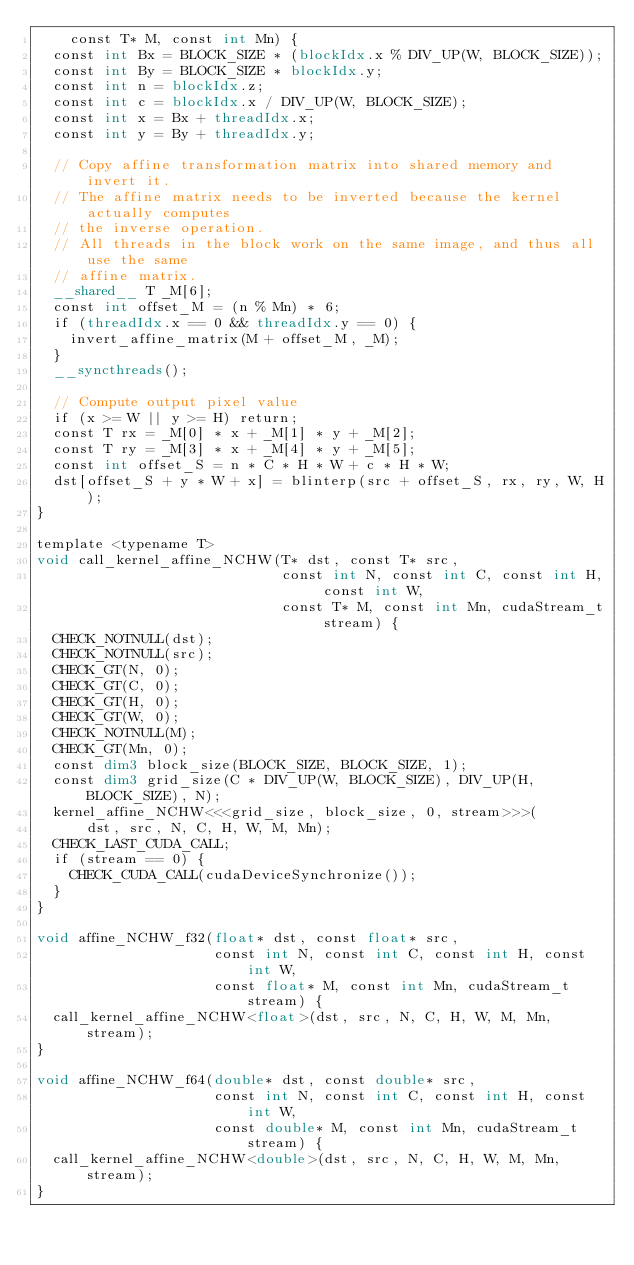Convert code to text. <code><loc_0><loc_0><loc_500><loc_500><_Cuda_>    const T* M, const int Mn) {
  const int Bx = BLOCK_SIZE * (blockIdx.x % DIV_UP(W, BLOCK_SIZE));
  const int By = BLOCK_SIZE * blockIdx.y;
  const int n = blockIdx.z;
  const int c = blockIdx.x / DIV_UP(W, BLOCK_SIZE);
  const int x = Bx + threadIdx.x;
  const int y = By + threadIdx.y;

  // Copy affine transformation matrix into shared memory and invert it.
  // The affine matrix needs to be inverted because the kernel actually computes
  // the inverse operation.
  // All threads in the block work on the same image, and thus all use the same
  // affine matrix.
  __shared__ T _M[6];
  const int offset_M = (n % Mn) * 6;
  if (threadIdx.x == 0 && threadIdx.y == 0) {
    invert_affine_matrix(M + offset_M, _M);
  }
  __syncthreads();

  // Compute output pixel value
  if (x >= W || y >= H) return;
  const T rx = _M[0] * x + _M[1] * y + _M[2];
  const T ry = _M[3] * x + _M[4] * y + _M[5];
  const int offset_S = n * C * H * W + c * H * W;
  dst[offset_S + y * W + x] = blinterp(src + offset_S, rx, ry, W, H);
}

template <typename T>
void call_kernel_affine_NCHW(T* dst, const T* src,
                             const int N, const int C, const int H, const int W,
                             const T* M, const int Mn, cudaStream_t stream) {
  CHECK_NOTNULL(dst);
  CHECK_NOTNULL(src);
  CHECK_GT(N, 0);
  CHECK_GT(C, 0);
  CHECK_GT(H, 0);
  CHECK_GT(W, 0);
  CHECK_NOTNULL(M);
  CHECK_GT(Mn, 0);
  const dim3 block_size(BLOCK_SIZE, BLOCK_SIZE, 1);
  const dim3 grid_size(C * DIV_UP(W, BLOCK_SIZE), DIV_UP(H, BLOCK_SIZE), N);
  kernel_affine_NCHW<<<grid_size, block_size, 0, stream>>>(
      dst, src, N, C, H, W, M, Mn);
  CHECK_LAST_CUDA_CALL;
  if (stream == 0) {
    CHECK_CUDA_CALL(cudaDeviceSynchronize());
  }
}

void affine_NCHW_f32(float* dst, const float* src,
                     const int N, const int C, const int H, const int W,
                     const float* M, const int Mn, cudaStream_t stream) {
  call_kernel_affine_NCHW<float>(dst, src, N, C, H, W, M, Mn, stream);
}

void affine_NCHW_f64(double* dst, const double* src,
                     const int N, const int C, const int H, const int W,
                     const double* M, const int Mn, cudaStream_t stream) {
  call_kernel_affine_NCHW<double>(dst, src, N, C, H, W, M, Mn, stream);
}
</code> 